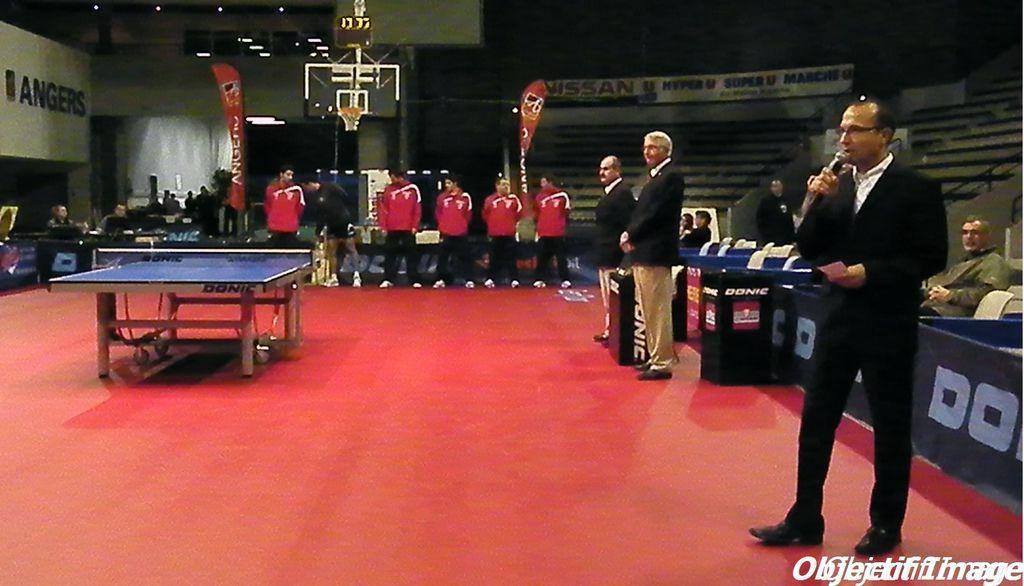Please provide a concise description of this image. In this image there is a TT table in the middle of the stage, beside that there are so many people standing in the line also there is a man speaking in the microphone, behind him there are some people sitting in chairs. 